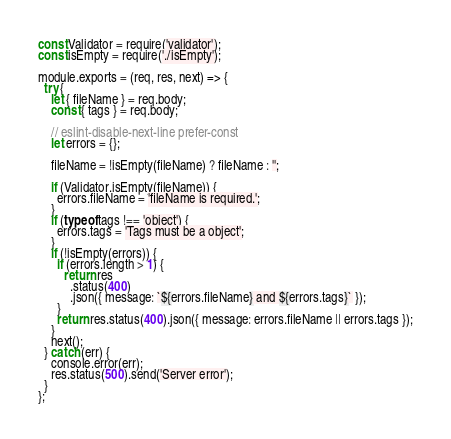Convert code to text. <code><loc_0><loc_0><loc_500><loc_500><_JavaScript_>const Validator = require('validator');
const isEmpty = require('./isEmpty');

module.exports = (req, res, next) => {
  try {
    let { fileName } = req.body;
    const { tags } = req.body;

    // eslint-disable-next-line prefer-const
    let errors = {};

    fileName = !isEmpty(fileName) ? fileName : '';

    if (Validator.isEmpty(fileName)) {
      errors.fileName = 'fileName is required.';
    }
    if (typeof tags !== 'object') {
      errors.tags = 'Tags must be a object';
    }
    if (!isEmpty(errors)) {
      if (errors.length > 1) {
        return res
          .status(400)
          .json({ message: `${errors.fileName} and ${errors.tags}` });
      }
      return res.status(400).json({ message: errors.fileName || errors.tags });
    }
    next();
  } catch (err) {
    console.error(err);
    res.status(500).send('Server error');
  }
};
</code> 